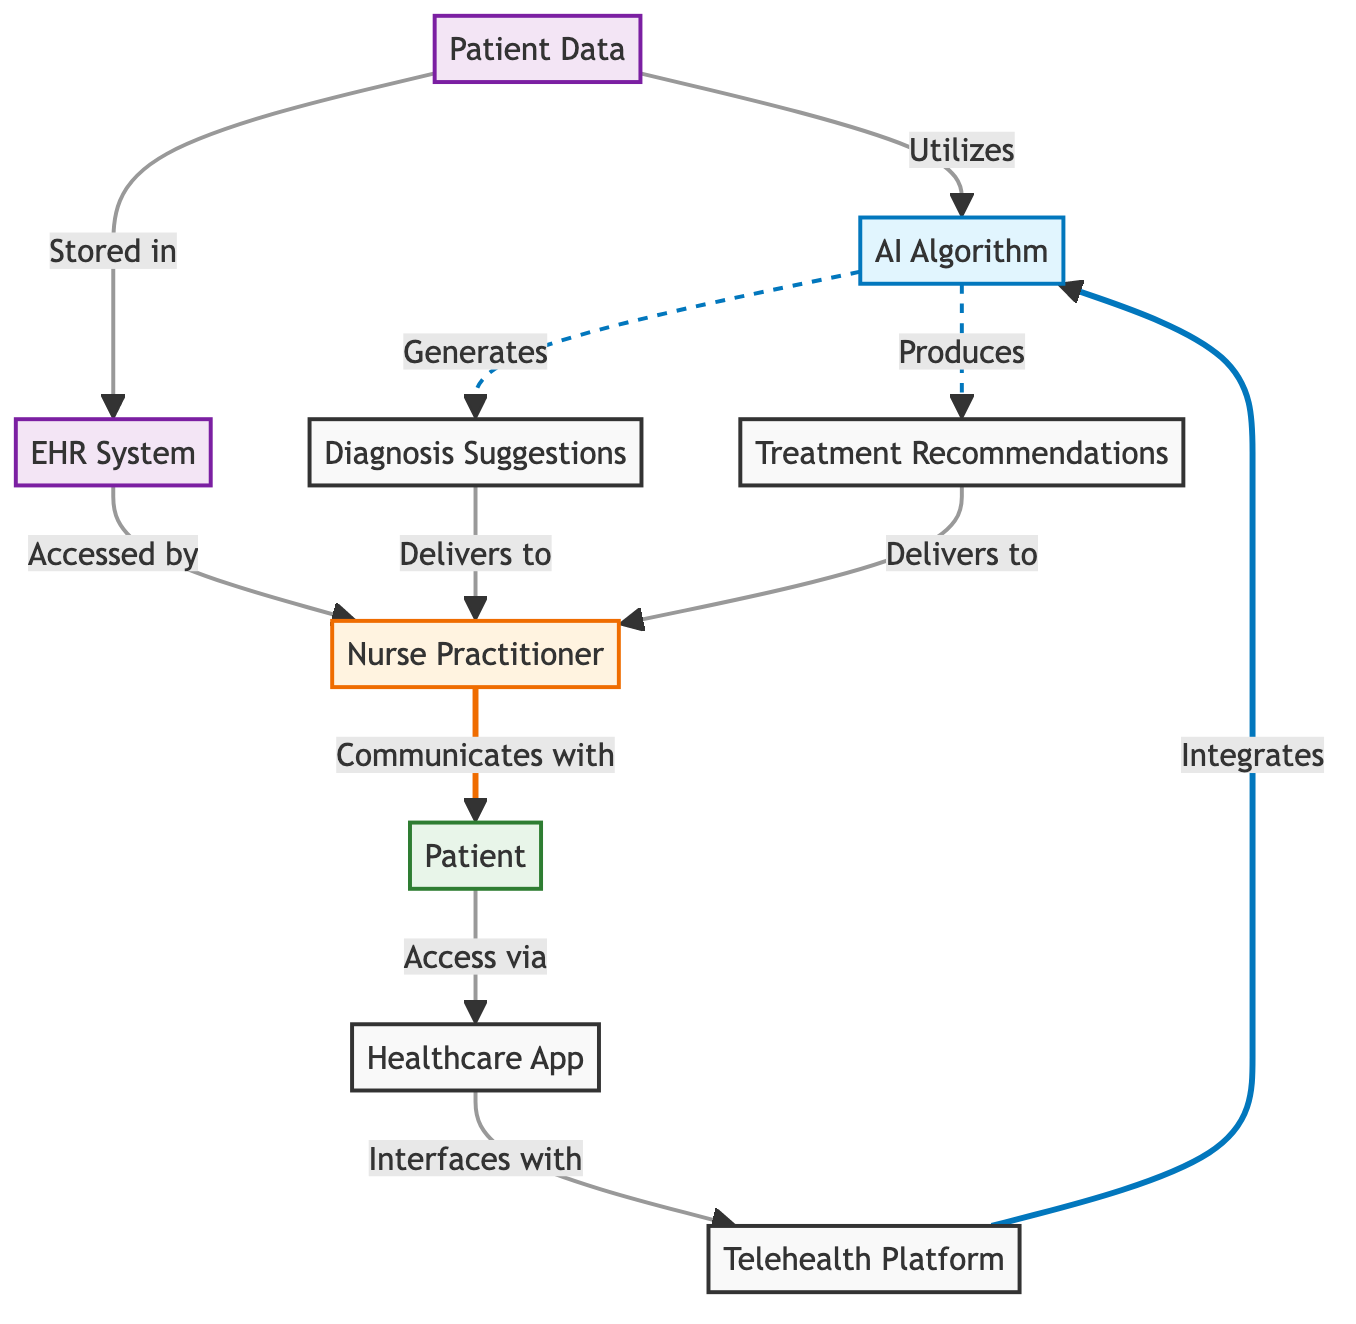What's the total number of nodes in the diagram? The diagram includes the following nodes: AI Algorithm, Telehealth Platform, Patient, Nurse Practitioner, Patient Data, EHR System, Diagnosis Suggestions, Treatment Recommendations, and Healthcare Application. Counting these, there are 9 nodes in total.
Answer: 9 What type of data does the AI Algorithm utilize? The AI Algorithm utilizes Patient Data, which is indicated by the edge labeled "Utilizes" that connects Patient Data to the AI Algorithm.
Answer: Patient Data Which node delivers Diagnosis Suggestions to the Nurse Practitioner? Diagnosis Suggestions is delivered to the Nurse Practitioner, as shown by the edge labeled "Delivers to" connecting Diagnosis Suggestions to the Nurse Practitioner.
Answer: Nurse Practitioner How does the Patient access the Healthcare Application? The Patient accesses the Healthcare Application via the edge labeled "Access via," which connects the Patient to the Healthcare Application.
Answer: Access via What is the relationship between the EHR System and the Nurse Practitioner? The EHR System is accessed by the Nurse Practitioner, as indicated by the edge labeled "Accessed by" that connects the EHR System to the Nurse Practitioner.
Answer: Accessed by How many edges are there in the diagram? The diagram consists of multiple edges that represent the relationships between the nodes. By counting all edges listed, there are a total of 10 edges.
Answer: 10 What generates Treatment Recommendations in the diagram? The AI Algorithm produces Treatment Recommendations, as evidenced by the edge labeled "Produces" that connects the AI Algorithm to Treatment Recommendations.
Answer: AI Algorithm Which system is patient data stored in? Patient data is stored in the EHR System, indicated by the edge labeled "Stored in" connecting Patient Data to the EHR System.
Answer: EHR System How does the Telehealth Platform interact with the AI Algorithm? The Telehealth Platform integrates with the AI Algorithm, as stated by the edge labeled "Integrates" connecting the Telehealth Platform to the AI Algorithm.
Answer: Integrates 